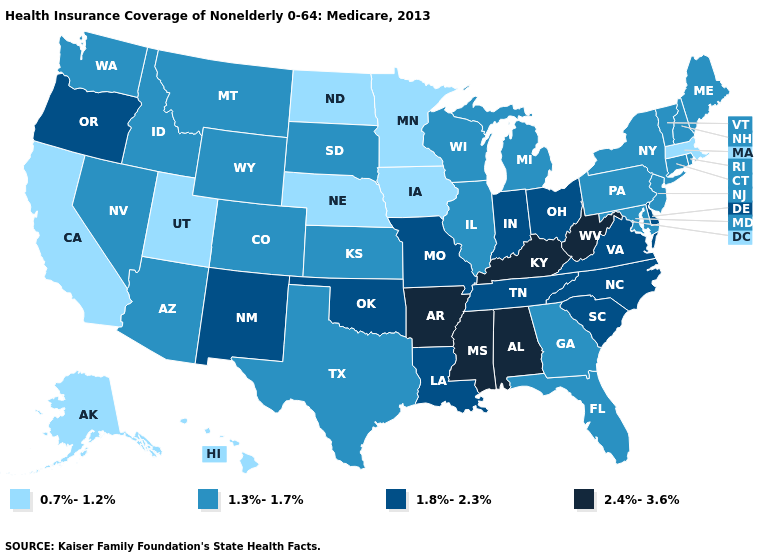Does Oregon have the highest value in the West?
Concise answer only. Yes. How many symbols are there in the legend?
Write a very short answer. 4. Does Texas have the lowest value in the South?
Quick response, please. Yes. What is the value of Texas?
Write a very short answer. 1.3%-1.7%. Among the states that border South Dakota , does Nebraska have the lowest value?
Concise answer only. Yes. Among the states that border Arkansas , does Oklahoma have the highest value?
Give a very brief answer. No. Does the map have missing data?
Short answer required. No. Among the states that border Minnesota , which have the lowest value?
Concise answer only. Iowa, North Dakota. Does Oregon have the same value as West Virginia?
Short answer required. No. Which states have the lowest value in the USA?
Write a very short answer. Alaska, California, Hawaii, Iowa, Massachusetts, Minnesota, Nebraska, North Dakota, Utah. What is the lowest value in the Northeast?
Be succinct. 0.7%-1.2%. Does Georgia have a higher value than Hawaii?
Concise answer only. Yes. What is the value of Tennessee?
Answer briefly. 1.8%-2.3%. Name the states that have a value in the range 0.7%-1.2%?
Keep it brief. Alaska, California, Hawaii, Iowa, Massachusetts, Minnesota, Nebraska, North Dakota, Utah. 